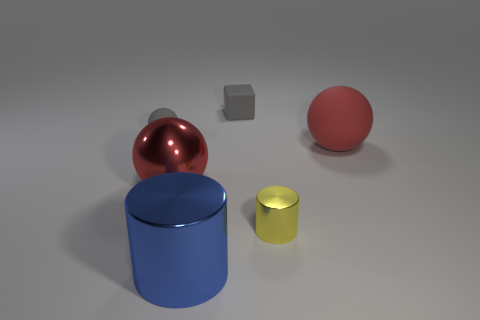Add 3 tiny matte things. How many objects exist? 9 Subtract all blocks. How many objects are left? 5 Subtract 0 purple spheres. How many objects are left? 6 Subtract all gray rubber cubes. Subtract all tiny yellow metallic cylinders. How many objects are left? 4 Add 1 small blocks. How many small blocks are left? 2 Add 2 small green matte blocks. How many small green matte blocks exist? 2 